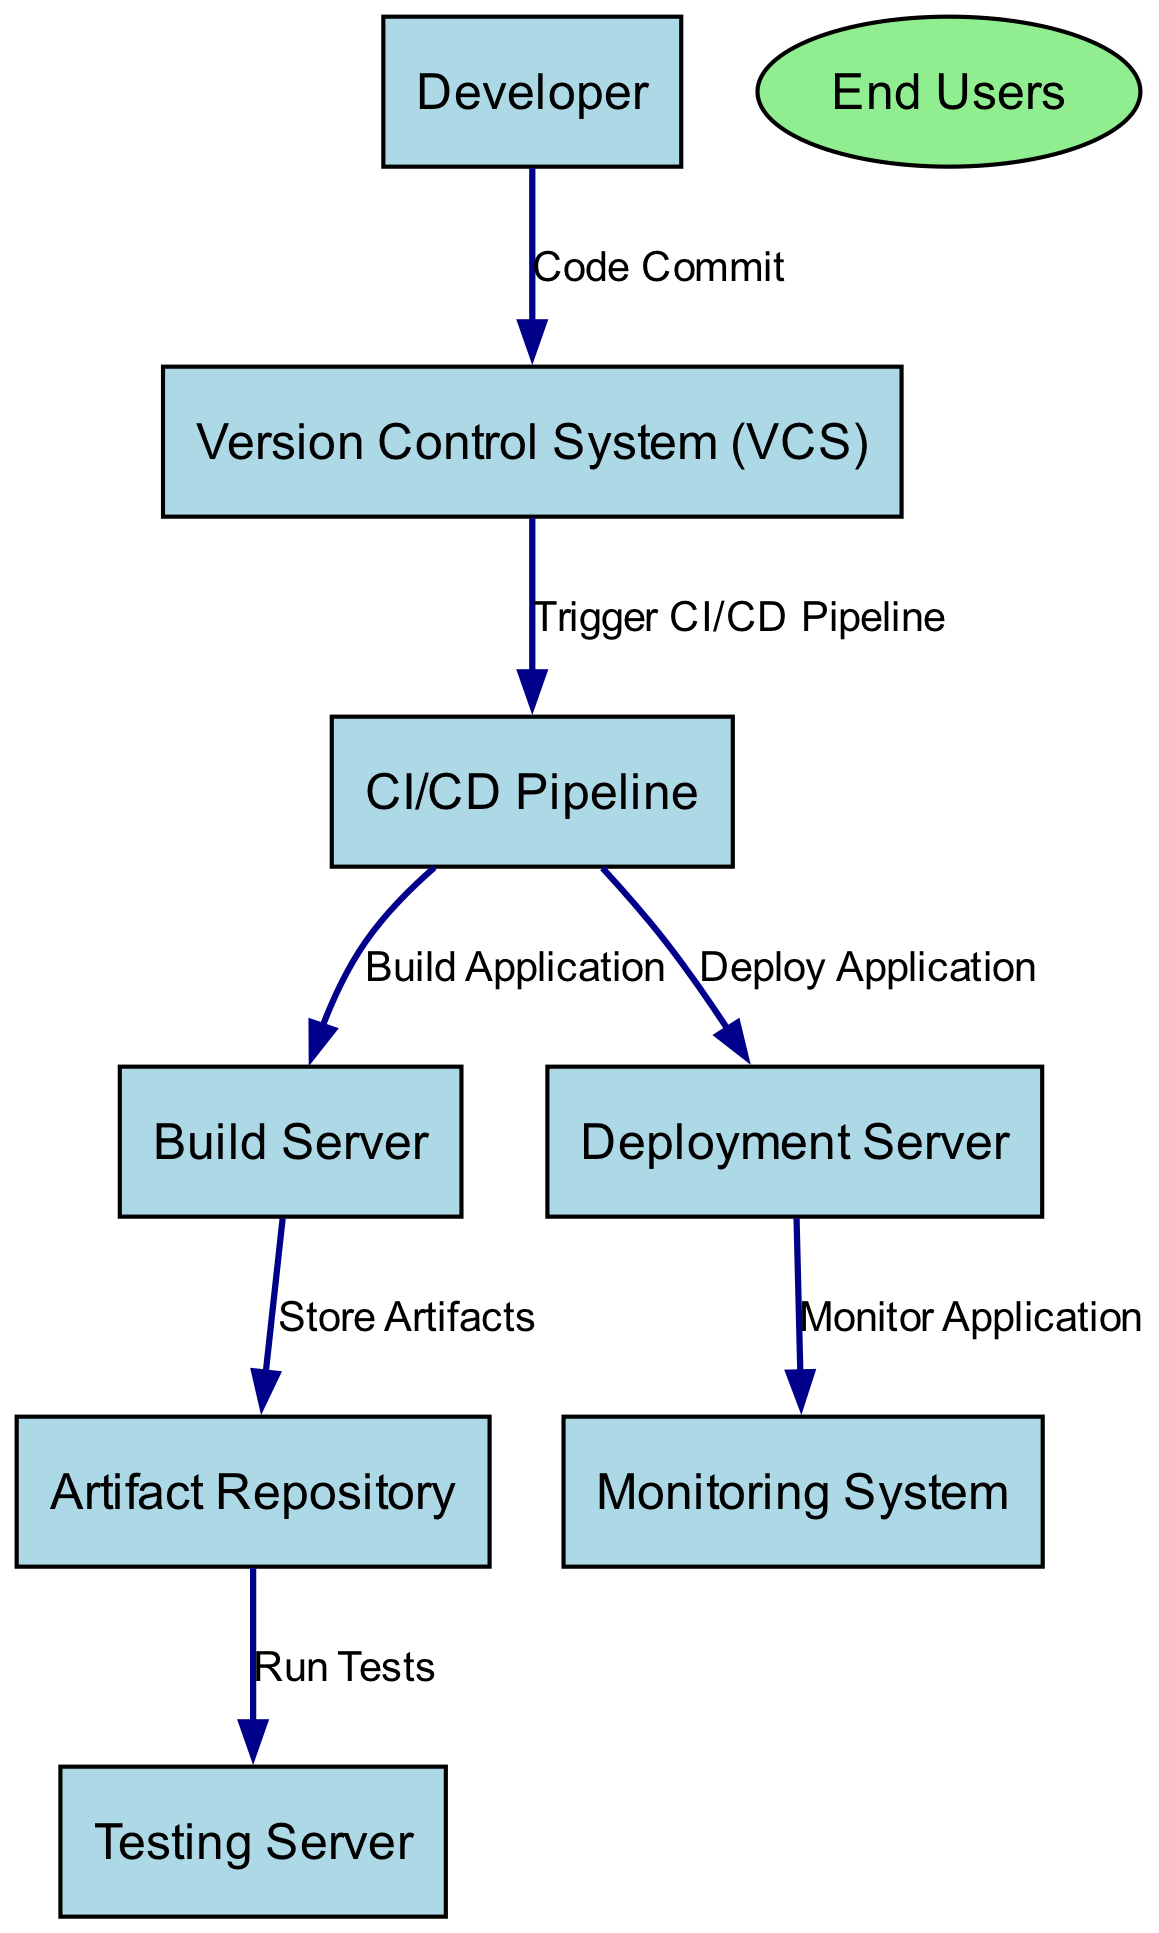What is the primary function of the CI/CD Pipeline? The CI/CD Pipeline serves as the automated workflow for continuous integration and continuous deployment, managing the overall process of code commits through to deployment.
Answer: Automated workflow for continuous integration and continuous deployment How many external entities are present in the diagram? The diagram features one external entity, which is the End Users. This can be counted by identifying the entities depicted as ellipses.
Answer: One What triggers the CI/CD Pipeline? The CI/CD Pipeline is triggered by a commit made to the Version Control System (VCS) by the Developer, indicating the start of the automated processes.
Answer: Code Commit Which server is responsible for running automated tests? The Testing Server is tasked with executing the automated tests, ensuring the quality and reliability of the built application.
Answer: Testing Server What follows the Build Application process? After the Build Application process conducted by the Build Server, the next step is to store the compiled and built artifacts in the Artifact Repository.
Answer: Store Artifacts What does the Monitoring System do? The Monitoring System tracks the performance and health of the deployed application, providing insights on its operational status.
Answer: Monitor Application What is the flow of data from the Artifact Repository to the Testing Server? Data flows from the Artifact Repository to the Testing Server under the process of Run Tests, which depicts the workflow of verifying application functionality post-build.
Answer: Run Tests How many processes are listed in the diagram? There are seven processes outlined in the diagram, covering everything from code commits to monitoring the application. This can be determined by counting the listed processes within the processes section.
Answer: Seven Which component receives output from the Deployment Server? The Monitoring System receives output from the Deployment Server, which is responsible for maintaining oversight of the application's operational state.
Answer: Monitoring System What type of system is the Build Server considered? The Build Server is primarily regarded as a server that compiles and constructs the source code, playing a crucial role in the CI/CD pipeline.
Answer: Build Server 